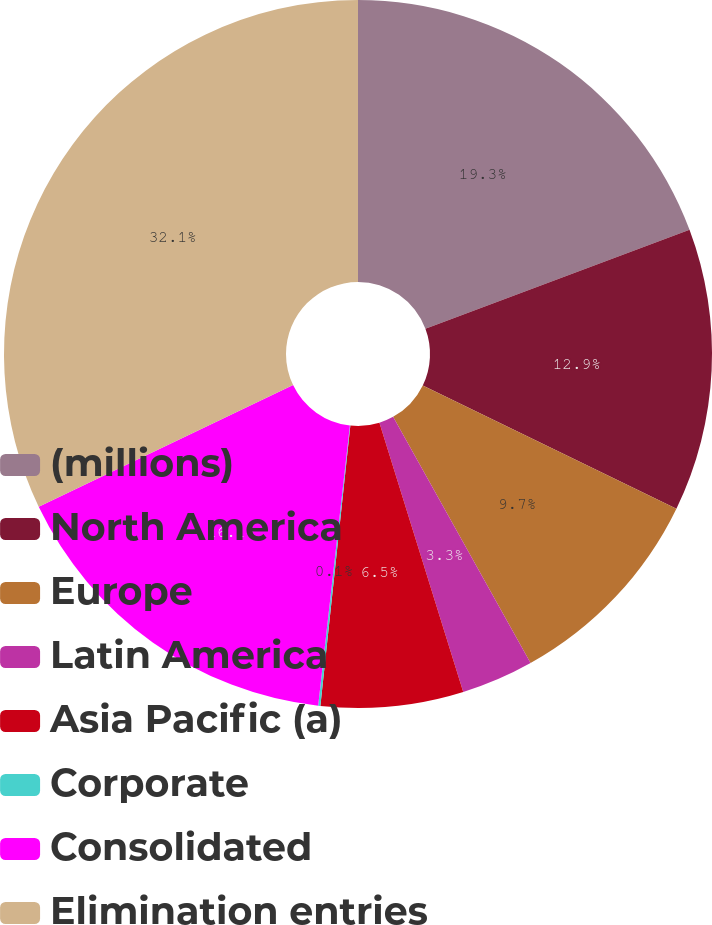Convert chart to OTSL. <chart><loc_0><loc_0><loc_500><loc_500><pie_chart><fcel>(millions)<fcel>North America<fcel>Europe<fcel>Latin America<fcel>Asia Pacific (a)<fcel>Corporate<fcel>Consolidated<fcel>Elimination entries<nl><fcel>19.3%<fcel>12.9%<fcel>9.7%<fcel>3.3%<fcel>6.5%<fcel>0.1%<fcel>16.1%<fcel>32.11%<nl></chart> 